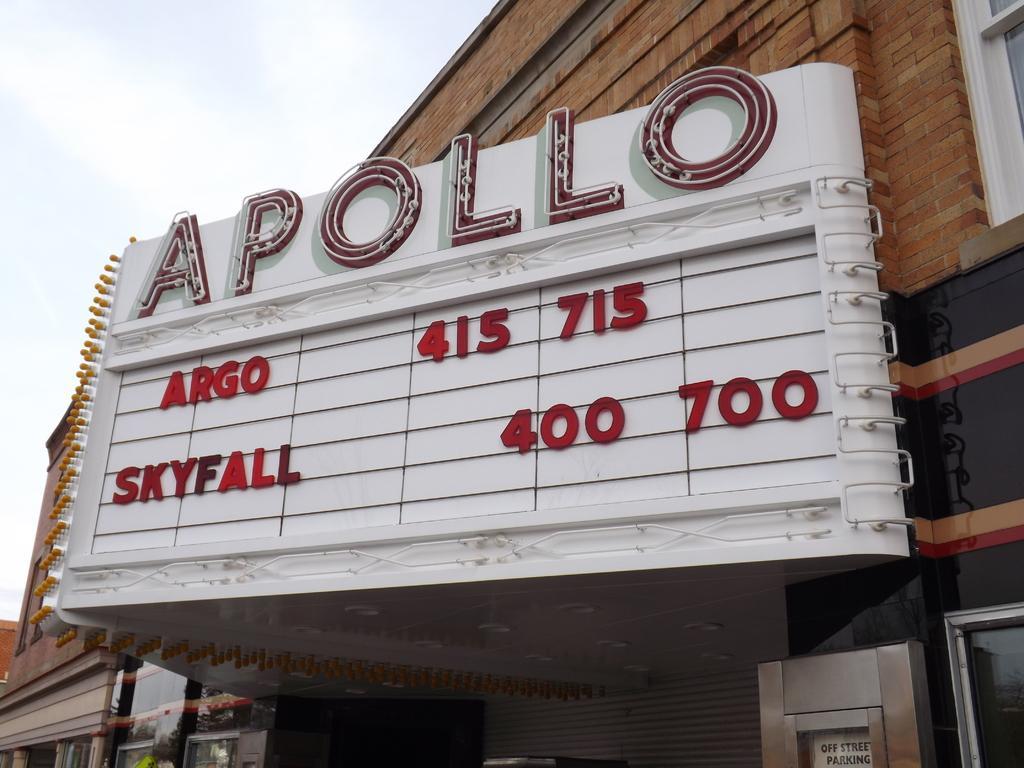Could you give a brief overview of what you see in this image? This image is taken outdoors. At the top of the image there is the sky with clouds. In the middle of the image there are a few buildings with walls, windows, doors and roofs. There is a board with a text on it. 